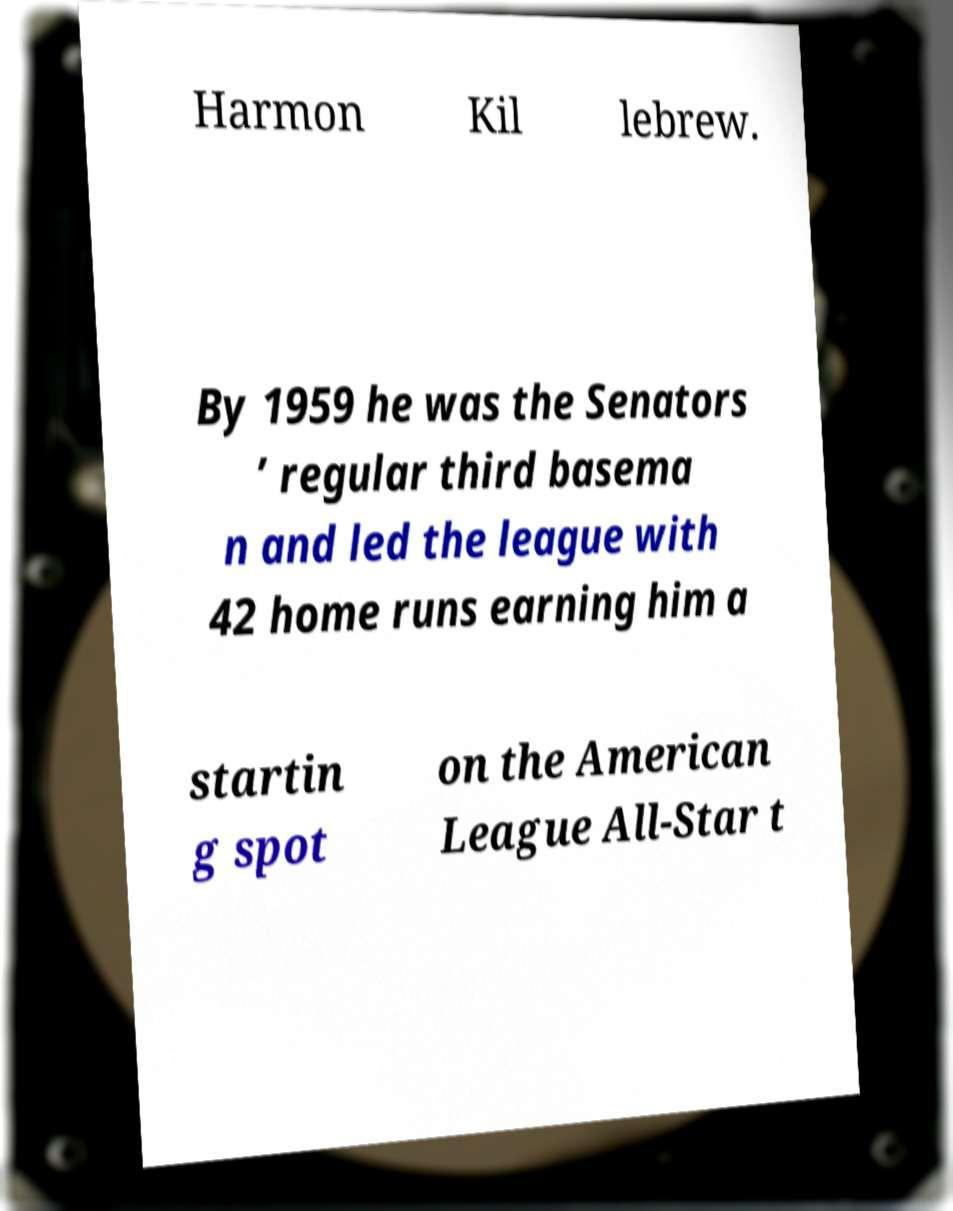There's text embedded in this image that I need extracted. Can you transcribe it verbatim? Harmon Kil lebrew. By 1959 he was the Senators ’ regular third basema n and led the league with 42 home runs earning him a startin g spot on the American League All-Star t 